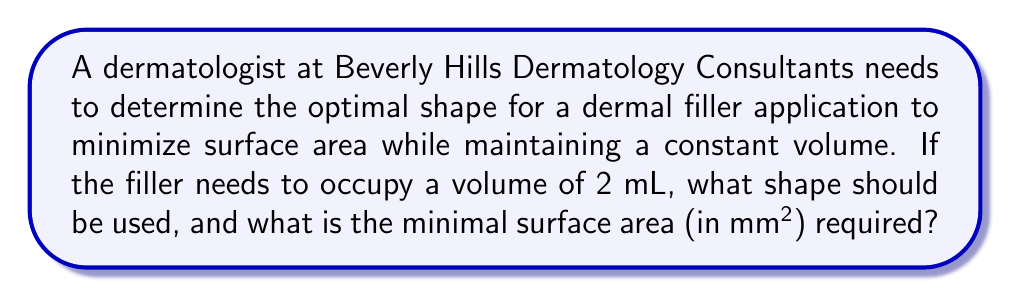Teach me how to tackle this problem. Let's approach this step-by-step:

1) The shape with the minimum surface area for a given volume is a sphere. This is a fundamental result in differential geometry.

2) For a sphere, we have the following relationships:
   Volume: $V = \frac{4}{3}\pi r^3$
   Surface Area: $A = 4\pi r^2$

3) We're given that the volume is 2 mL = 2000 mm³. Let's find the radius:

   $2000 = \frac{4}{3}\pi r^3$

4) Solving for r:
   
   $r^3 = \frac{2000 \cdot 3}{4\pi} \approx 477.46$
   
   $r \approx 7.82$ mm

5) Now that we have the radius, we can calculate the surface area:

   $A = 4\pi r^2$
   $A = 4\pi (7.82)^2$
   $A \approx 768.31$ mm²

Therefore, the minimal surface area is approximately 768.31 mm².
Answer: Sphere; 768.31 mm² 